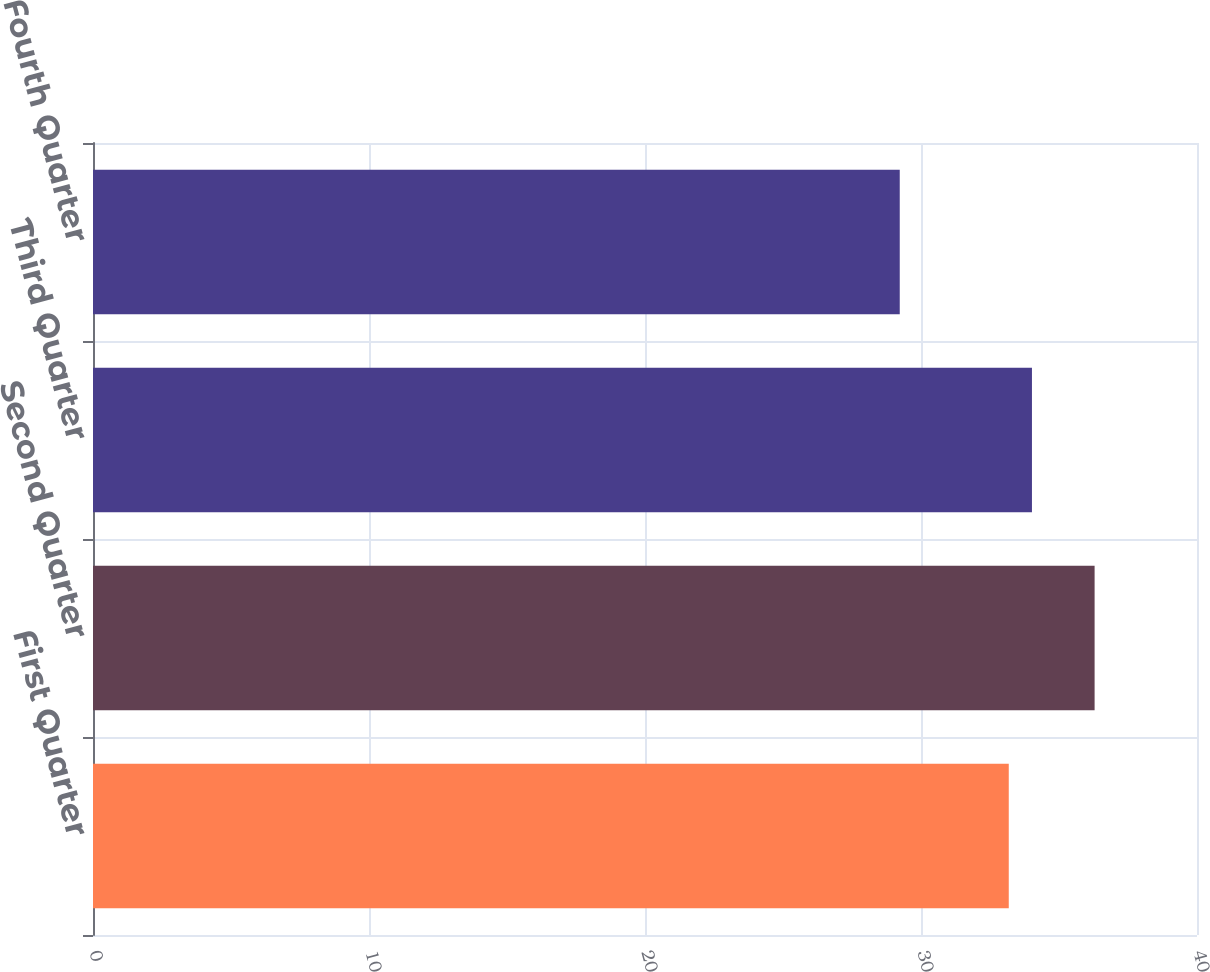<chart> <loc_0><loc_0><loc_500><loc_500><bar_chart><fcel>First Quarter<fcel>Second Quarter<fcel>Third Quarter<fcel>Fourth Quarter<nl><fcel>33.18<fcel>36.29<fcel>34.02<fcel>29.23<nl></chart> 